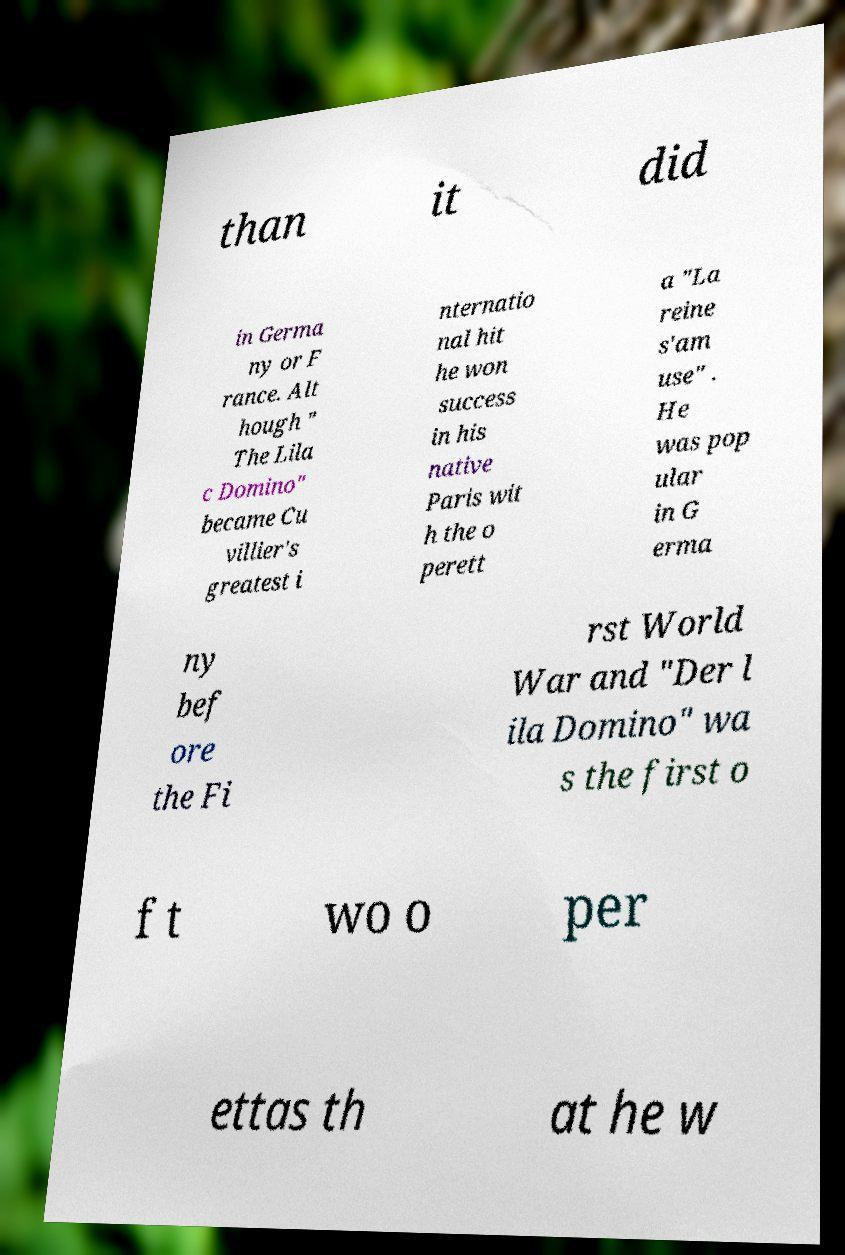I need the written content from this picture converted into text. Can you do that? than it did in Germa ny or F rance. Alt hough " The Lila c Domino" became Cu villier's greatest i nternatio nal hit he won success in his native Paris wit h the o perett a "La reine s'am use" . He was pop ular in G erma ny bef ore the Fi rst World War and "Der l ila Domino" wa s the first o f t wo o per ettas th at he w 